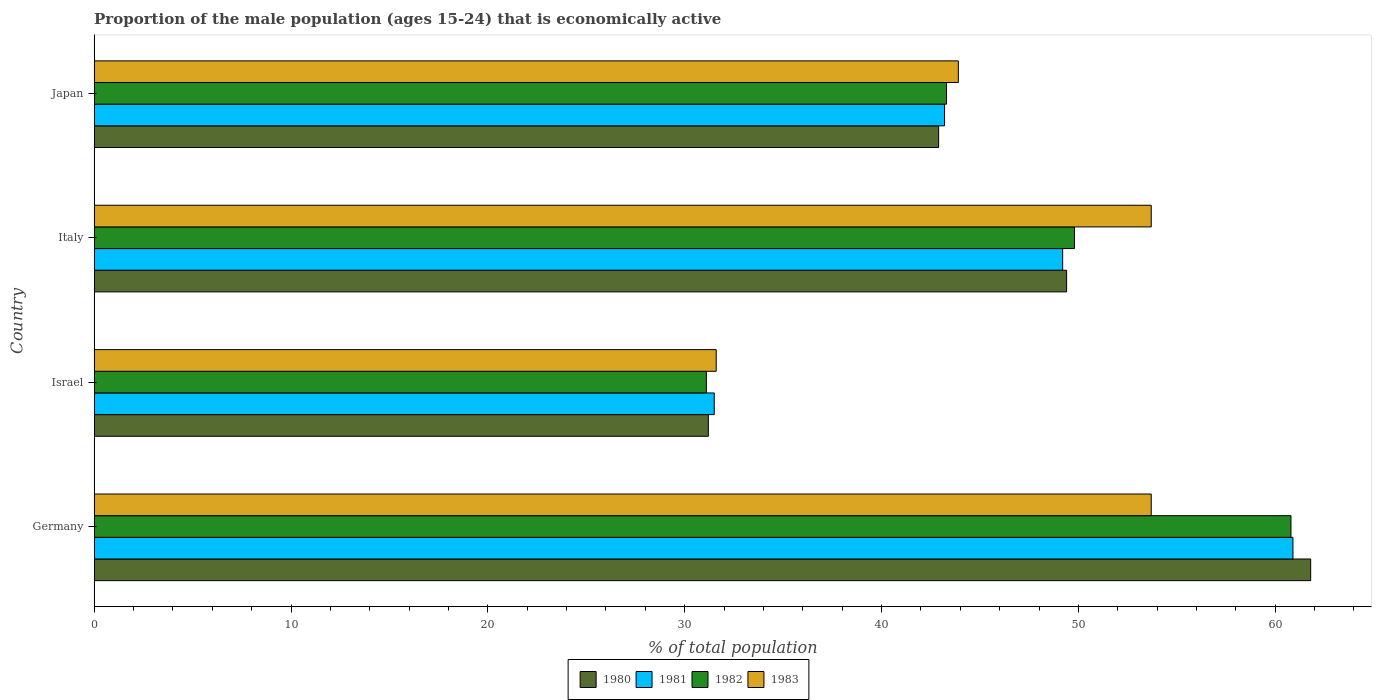How many bars are there on the 2nd tick from the bottom?
Make the answer very short. 4. What is the proportion of the male population that is economically active in 1980 in Italy?
Ensure brevity in your answer.  49.4. Across all countries, what is the maximum proportion of the male population that is economically active in 1980?
Keep it short and to the point. 61.8. Across all countries, what is the minimum proportion of the male population that is economically active in 1983?
Offer a terse response. 31.6. In which country was the proportion of the male population that is economically active in 1982 minimum?
Offer a terse response. Israel. What is the total proportion of the male population that is economically active in 1982 in the graph?
Offer a very short reply. 185. What is the difference between the proportion of the male population that is economically active in 1981 in Germany and that in Israel?
Provide a succinct answer. 29.4. What is the difference between the proportion of the male population that is economically active in 1983 in Israel and the proportion of the male population that is economically active in 1982 in Germany?
Give a very brief answer. -29.2. What is the average proportion of the male population that is economically active in 1981 per country?
Provide a succinct answer. 46.2. What is the ratio of the proportion of the male population that is economically active in 1980 in Germany to that in Italy?
Offer a terse response. 1.25. Is the proportion of the male population that is economically active in 1980 in Germany less than that in Italy?
Provide a short and direct response. No. Is the difference between the proportion of the male population that is economically active in 1983 in Italy and Japan greater than the difference between the proportion of the male population that is economically active in 1982 in Italy and Japan?
Ensure brevity in your answer.  Yes. What is the difference between the highest and the second highest proportion of the male population that is economically active in 1980?
Make the answer very short. 12.4. What is the difference between the highest and the lowest proportion of the male population that is economically active in 1981?
Provide a short and direct response. 29.4. In how many countries, is the proportion of the male population that is economically active in 1981 greater than the average proportion of the male population that is economically active in 1981 taken over all countries?
Your response must be concise. 2. Is the sum of the proportion of the male population that is economically active in 1980 in Italy and Japan greater than the maximum proportion of the male population that is economically active in 1982 across all countries?
Provide a short and direct response. Yes. What does the 3rd bar from the top in Israel represents?
Offer a very short reply. 1981. What does the 4th bar from the bottom in Japan represents?
Offer a terse response. 1983. Is it the case that in every country, the sum of the proportion of the male population that is economically active in 1983 and proportion of the male population that is economically active in 1981 is greater than the proportion of the male population that is economically active in 1982?
Keep it short and to the point. Yes. Are all the bars in the graph horizontal?
Offer a very short reply. Yes. How many countries are there in the graph?
Your response must be concise. 4. Does the graph contain any zero values?
Ensure brevity in your answer.  No. Where does the legend appear in the graph?
Offer a terse response. Bottom center. How many legend labels are there?
Offer a very short reply. 4. How are the legend labels stacked?
Ensure brevity in your answer.  Horizontal. What is the title of the graph?
Offer a very short reply. Proportion of the male population (ages 15-24) that is economically active. What is the label or title of the X-axis?
Ensure brevity in your answer.  % of total population. What is the % of total population of 1980 in Germany?
Keep it short and to the point. 61.8. What is the % of total population of 1981 in Germany?
Make the answer very short. 60.9. What is the % of total population of 1982 in Germany?
Your response must be concise. 60.8. What is the % of total population of 1983 in Germany?
Provide a succinct answer. 53.7. What is the % of total population of 1980 in Israel?
Keep it short and to the point. 31.2. What is the % of total population of 1981 in Israel?
Offer a terse response. 31.5. What is the % of total population of 1982 in Israel?
Provide a succinct answer. 31.1. What is the % of total population in 1983 in Israel?
Provide a succinct answer. 31.6. What is the % of total population in 1980 in Italy?
Provide a short and direct response. 49.4. What is the % of total population of 1981 in Italy?
Provide a succinct answer. 49.2. What is the % of total population of 1982 in Italy?
Your answer should be compact. 49.8. What is the % of total population in 1983 in Italy?
Give a very brief answer. 53.7. What is the % of total population of 1980 in Japan?
Offer a terse response. 42.9. What is the % of total population in 1981 in Japan?
Give a very brief answer. 43.2. What is the % of total population of 1982 in Japan?
Provide a succinct answer. 43.3. What is the % of total population in 1983 in Japan?
Give a very brief answer. 43.9. Across all countries, what is the maximum % of total population of 1980?
Give a very brief answer. 61.8. Across all countries, what is the maximum % of total population of 1981?
Offer a very short reply. 60.9. Across all countries, what is the maximum % of total population in 1982?
Offer a very short reply. 60.8. Across all countries, what is the maximum % of total population in 1983?
Make the answer very short. 53.7. Across all countries, what is the minimum % of total population of 1980?
Offer a terse response. 31.2. Across all countries, what is the minimum % of total population in 1981?
Provide a short and direct response. 31.5. Across all countries, what is the minimum % of total population in 1982?
Your response must be concise. 31.1. Across all countries, what is the minimum % of total population in 1983?
Your answer should be compact. 31.6. What is the total % of total population in 1980 in the graph?
Provide a short and direct response. 185.3. What is the total % of total population of 1981 in the graph?
Make the answer very short. 184.8. What is the total % of total population of 1982 in the graph?
Keep it short and to the point. 185. What is the total % of total population of 1983 in the graph?
Your response must be concise. 182.9. What is the difference between the % of total population in 1980 in Germany and that in Israel?
Offer a very short reply. 30.6. What is the difference between the % of total population of 1981 in Germany and that in Israel?
Keep it short and to the point. 29.4. What is the difference between the % of total population in 1982 in Germany and that in Israel?
Keep it short and to the point. 29.7. What is the difference between the % of total population in 1983 in Germany and that in Israel?
Offer a terse response. 22.1. What is the difference between the % of total population of 1982 in Germany and that in Italy?
Give a very brief answer. 11. What is the difference between the % of total population of 1980 in Germany and that in Japan?
Your response must be concise. 18.9. What is the difference between the % of total population in 1980 in Israel and that in Italy?
Provide a succinct answer. -18.2. What is the difference between the % of total population in 1981 in Israel and that in Italy?
Your response must be concise. -17.7. What is the difference between the % of total population in 1982 in Israel and that in Italy?
Provide a succinct answer. -18.7. What is the difference between the % of total population of 1983 in Israel and that in Italy?
Provide a succinct answer. -22.1. What is the difference between the % of total population in 1981 in Israel and that in Japan?
Offer a very short reply. -11.7. What is the difference between the % of total population in 1982 in Israel and that in Japan?
Make the answer very short. -12.2. What is the difference between the % of total population in 1982 in Italy and that in Japan?
Your answer should be compact. 6.5. What is the difference between the % of total population in 1980 in Germany and the % of total population in 1981 in Israel?
Your response must be concise. 30.3. What is the difference between the % of total population in 1980 in Germany and the % of total population in 1982 in Israel?
Keep it short and to the point. 30.7. What is the difference between the % of total population in 1980 in Germany and the % of total population in 1983 in Israel?
Offer a very short reply. 30.2. What is the difference between the % of total population of 1981 in Germany and the % of total population of 1982 in Israel?
Your answer should be compact. 29.8. What is the difference between the % of total population of 1981 in Germany and the % of total population of 1983 in Israel?
Provide a short and direct response. 29.3. What is the difference between the % of total population of 1982 in Germany and the % of total population of 1983 in Israel?
Offer a very short reply. 29.2. What is the difference between the % of total population in 1980 in Germany and the % of total population in 1981 in Italy?
Keep it short and to the point. 12.6. What is the difference between the % of total population in 1980 in Germany and the % of total population in 1983 in Italy?
Provide a succinct answer. 8.1. What is the difference between the % of total population of 1981 in Germany and the % of total population of 1982 in Italy?
Your response must be concise. 11.1. What is the difference between the % of total population of 1981 in Germany and the % of total population of 1983 in Italy?
Keep it short and to the point. 7.2. What is the difference between the % of total population in 1980 in Germany and the % of total population in 1981 in Japan?
Make the answer very short. 18.6. What is the difference between the % of total population in 1980 in Germany and the % of total population in 1982 in Japan?
Your answer should be very brief. 18.5. What is the difference between the % of total population of 1981 in Germany and the % of total population of 1982 in Japan?
Provide a succinct answer. 17.6. What is the difference between the % of total population in 1981 in Germany and the % of total population in 1983 in Japan?
Make the answer very short. 17. What is the difference between the % of total population of 1982 in Germany and the % of total population of 1983 in Japan?
Ensure brevity in your answer.  16.9. What is the difference between the % of total population in 1980 in Israel and the % of total population in 1981 in Italy?
Offer a terse response. -18. What is the difference between the % of total population in 1980 in Israel and the % of total population in 1982 in Italy?
Offer a very short reply. -18.6. What is the difference between the % of total population of 1980 in Israel and the % of total population of 1983 in Italy?
Make the answer very short. -22.5. What is the difference between the % of total population in 1981 in Israel and the % of total population in 1982 in Italy?
Offer a very short reply. -18.3. What is the difference between the % of total population in 1981 in Israel and the % of total population in 1983 in Italy?
Ensure brevity in your answer.  -22.2. What is the difference between the % of total population in 1982 in Israel and the % of total population in 1983 in Italy?
Offer a very short reply. -22.6. What is the difference between the % of total population in 1980 in Israel and the % of total population in 1981 in Japan?
Provide a short and direct response. -12. What is the difference between the % of total population in 1980 in Israel and the % of total population in 1982 in Japan?
Provide a short and direct response. -12.1. What is the difference between the % of total population of 1981 in Israel and the % of total population of 1983 in Japan?
Your answer should be compact. -12.4. What is the difference between the % of total population in 1982 in Israel and the % of total population in 1983 in Japan?
Keep it short and to the point. -12.8. What is the difference between the % of total population in 1980 in Italy and the % of total population in 1982 in Japan?
Offer a very short reply. 6.1. What is the difference between the % of total population in 1980 in Italy and the % of total population in 1983 in Japan?
Your answer should be compact. 5.5. What is the difference between the % of total population of 1981 in Italy and the % of total population of 1983 in Japan?
Provide a succinct answer. 5.3. What is the difference between the % of total population of 1982 in Italy and the % of total population of 1983 in Japan?
Offer a very short reply. 5.9. What is the average % of total population of 1980 per country?
Your answer should be compact. 46.33. What is the average % of total population of 1981 per country?
Your answer should be very brief. 46.2. What is the average % of total population of 1982 per country?
Offer a terse response. 46.25. What is the average % of total population of 1983 per country?
Offer a terse response. 45.73. What is the difference between the % of total population of 1980 and % of total population of 1981 in Germany?
Your response must be concise. 0.9. What is the difference between the % of total population in 1980 and % of total population in 1983 in Germany?
Give a very brief answer. 8.1. What is the difference between the % of total population in 1980 and % of total population in 1981 in Israel?
Your response must be concise. -0.3. What is the difference between the % of total population in 1980 and % of total population in 1981 in Italy?
Make the answer very short. 0.2. What is the difference between the % of total population of 1980 and % of total population of 1983 in Italy?
Ensure brevity in your answer.  -4.3. What is the difference between the % of total population of 1981 and % of total population of 1982 in Italy?
Make the answer very short. -0.6. What is the difference between the % of total population in 1981 and % of total population in 1983 in Italy?
Give a very brief answer. -4.5. What is the difference between the % of total population in 1982 and % of total population in 1983 in Italy?
Your response must be concise. -3.9. What is the difference between the % of total population in 1981 and % of total population in 1983 in Japan?
Make the answer very short. -0.7. What is the difference between the % of total population of 1982 and % of total population of 1983 in Japan?
Offer a very short reply. -0.6. What is the ratio of the % of total population in 1980 in Germany to that in Israel?
Offer a very short reply. 1.98. What is the ratio of the % of total population of 1981 in Germany to that in Israel?
Your response must be concise. 1.93. What is the ratio of the % of total population of 1982 in Germany to that in Israel?
Offer a terse response. 1.96. What is the ratio of the % of total population of 1983 in Germany to that in Israel?
Make the answer very short. 1.7. What is the ratio of the % of total population of 1980 in Germany to that in Italy?
Your answer should be compact. 1.25. What is the ratio of the % of total population of 1981 in Germany to that in Italy?
Keep it short and to the point. 1.24. What is the ratio of the % of total population of 1982 in Germany to that in Italy?
Offer a very short reply. 1.22. What is the ratio of the % of total population of 1983 in Germany to that in Italy?
Provide a short and direct response. 1. What is the ratio of the % of total population in 1980 in Germany to that in Japan?
Your response must be concise. 1.44. What is the ratio of the % of total population of 1981 in Germany to that in Japan?
Your answer should be very brief. 1.41. What is the ratio of the % of total population of 1982 in Germany to that in Japan?
Provide a succinct answer. 1.4. What is the ratio of the % of total population of 1983 in Germany to that in Japan?
Offer a very short reply. 1.22. What is the ratio of the % of total population in 1980 in Israel to that in Italy?
Ensure brevity in your answer.  0.63. What is the ratio of the % of total population of 1981 in Israel to that in Italy?
Ensure brevity in your answer.  0.64. What is the ratio of the % of total population of 1982 in Israel to that in Italy?
Make the answer very short. 0.62. What is the ratio of the % of total population of 1983 in Israel to that in Italy?
Keep it short and to the point. 0.59. What is the ratio of the % of total population of 1980 in Israel to that in Japan?
Offer a very short reply. 0.73. What is the ratio of the % of total population of 1981 in Israel to that in Japan?
Offer a terse response. 0.73. What is the ratio of the % of total population in 1982 in Israel to that in Japan?
Your answer should be very brief. 0.72. What is the ratio of the % of total population in 1983 in Israel to that in Japan?
Your answer should be very brief. 0.72. What is the ratio of the % of total population in 1980 in Italy to that in Japan?
Give a very brief answer. 1.15. What is the ratio of the % of total population in 1981 in Italy to that in Japan?
Offer a terse response. 1.14. What is the ratio of the % of total population in 1982 in Italy to that in Japan?
Keep it short and to the point. 1.15. What is the ratio of the % of total population in 1983 in Italy to that in Japan?
Ensure brevity in your answer.  1.22. What is the difference between the highest and the second highest % of total population of 1981?
Offer a very short reply. 11.7. What is the difference between the highest and the lowest % of total population in 1980?
Give a very brief answer. 30.6. What is the difference between the highest and the lowest % of total population in 1981?
Offer a very short reply. 29.4. What is the difference between the highest and the lowest % of total population of 1982?
Give a very brief answer. 29.7. What is the difference between the highest and the lowest % of total population of 1983?
Your answer should be very brief. 22.1. 